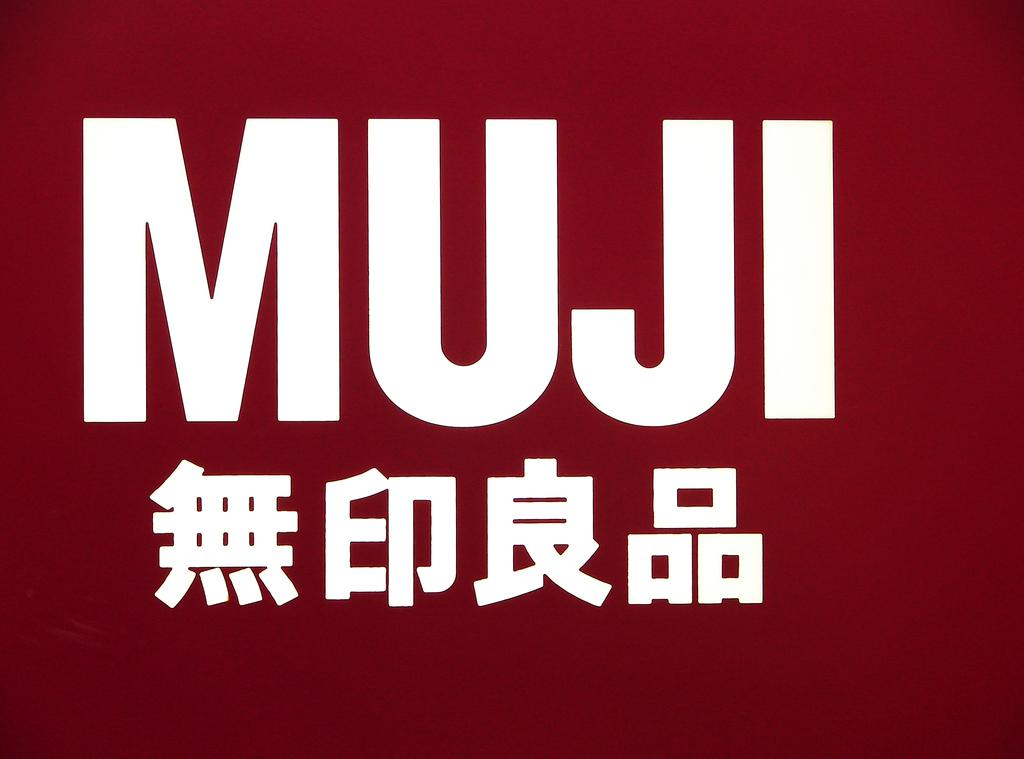<image>
Share a concise interpretation of the image provided. The red poster has the word MUJI on it 